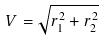Convert formula to latex. <formula><loc_0><loc_0><loc_500><loc_500>V = \sqrt { r _ { 1 } ^ { 2 } + r _ { 2 } ^ { 2 } }</formula> 